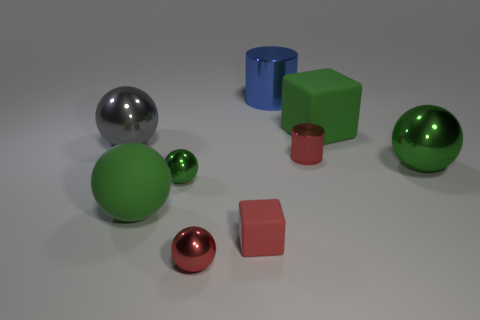Subtract all red spheres. How many spheres are left? 4 Subtract all tiny shiny spheres. How many spheres are left? 3 Subtract all cylinders. How many objects are left? 7 Subtract all purple cylinders. How many red cubes are left? 1 Subtract all tiny red things. Subtract all blue shiny balls. How many objects are left? 6 Add 4 small red metallic spheres. How many small red metallic spheres are left? 5 Add 6 large purple blocks. How many large purple blocks exist? 6 Subtract 0 gray cylinders. How many objects are left? 9 Subtract 2 balls. How many balls are left? 3 Subtract all green cylinders. Subtract all gray blocks. How many cylinders are left? 2 